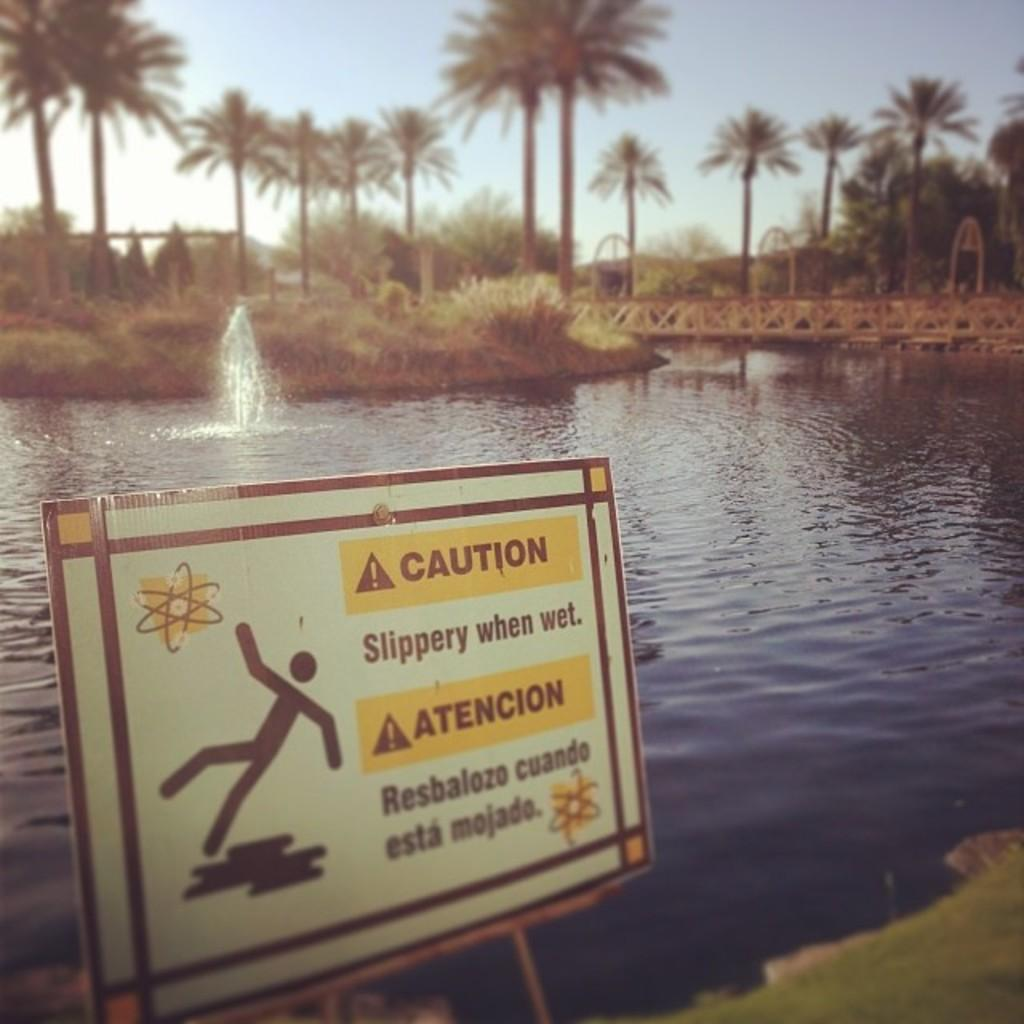What type of natural feature is present in the image? There is a river in the image. What safety measure is present near the river? There is a caution board in the image. How can people cross the river in the image? There is a bridge across the river in the image. What type of vegetation is present around the river? There are a lot of plants around the river in the image. What type of prose can be seen in the image? There is no prose present in the image; it is a visual representation of a river, caution board, bridge, and plants. 